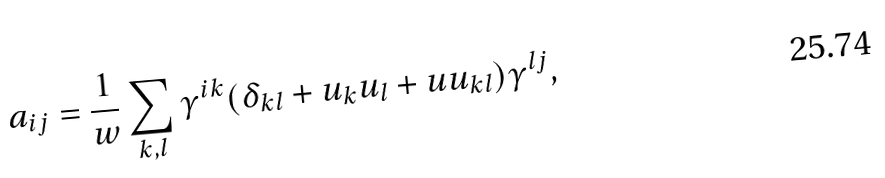Convert formula to latex. <formula><loc_0><loc_0><loc_500><loc_500>a _ { i j } = \frac { 1 } { w } \sum _ { k , l } \gamma ^ { i k } ( \delta _ { k l } + u _ { k } u _ { l } + u u _ { k l } ) \gamma ^ { l j } ,</formula> 